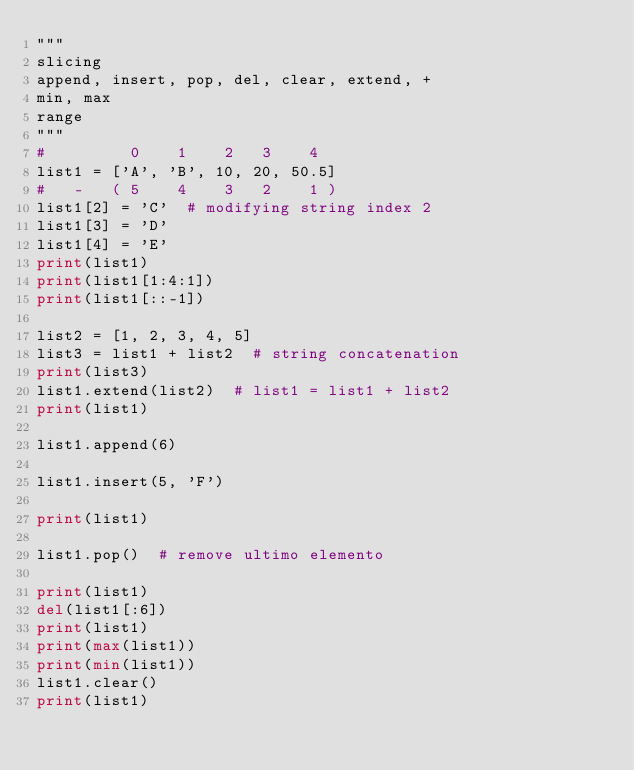Convert code to text. <code><loc_0><loc_0><loc_500><loc_500><_Python_>"""
slicing
append, insert, pop, del, clear, extend, +
min, max
range
"""
#         0    1    2   3    4
list1 = ['A', 'B', 10, 20, 50.5]
#   -   ( 5    4    3   2    1 )
list1[2] = 'C'  # modifying string index 2
list1[3] = 'D'
list1[4] = 'E'
print(list1)
print(list1[1:4:1])
print(list1[::-1])

list2 = [1, 2, 3, 4, 5]
list3 = list1 + list2  # string concatenation
print(list3)
list1.extend(list2)  # list1 = list1 + list2
print(list1)

list1.append(6)

list1.insert(5, 'F')

print(list1)

list1.pop()  # remove ultimo elemento

print(list1)
del(list1[:6])
print(list1)
print(max(list1))
print(min(list1))
list1.clear()
print(list1)
</code> 